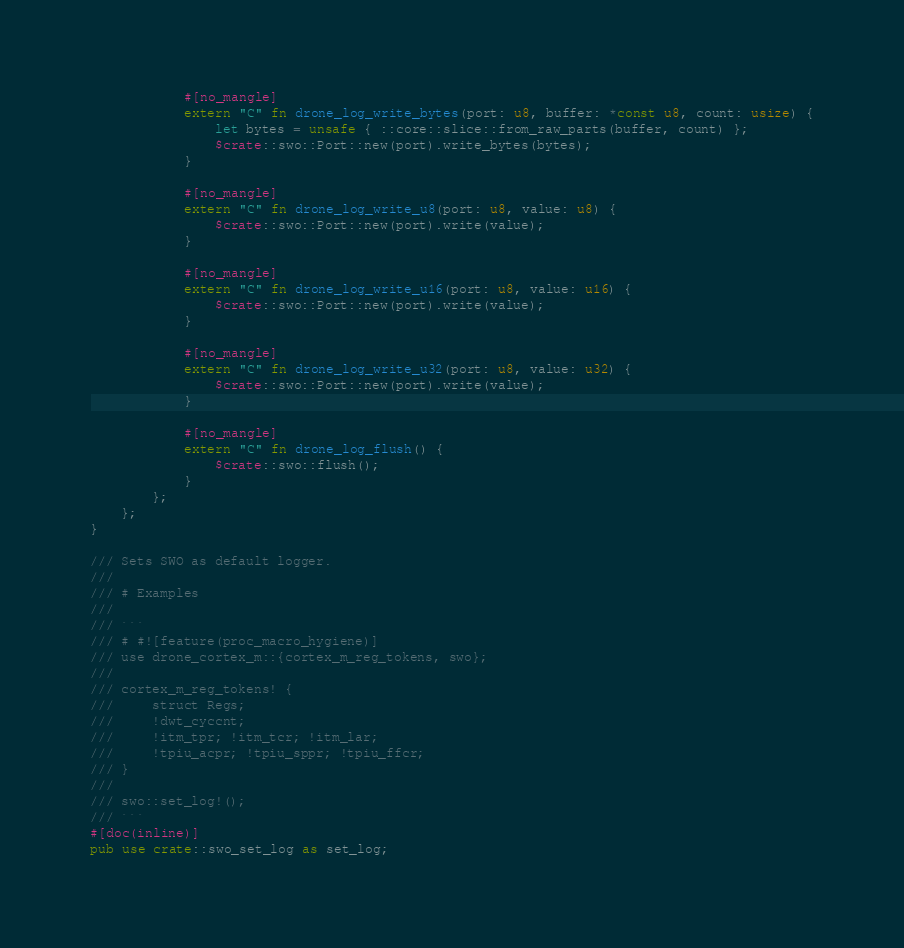Convert code to text. <code><loc_0><loc_0><loc_500><loc_500><_Rust_>            #[no_mangle]
            extern "C" fn drone_log_write_bytes(port: u8, buffer: *const u8, count: usize) {
                let bytes = unsafe { ::core::slice::from_raw_parts(buffer, count) };
                $crate::swo::Port::new(port).write_bytes(bytes);
            }

            #[no_mangle]
            extern "C" fn drone_log_write_u8(port: u8, value: u8) {
                $crate::swo::Port::new(port).write(value);
            }

            #[no_mangle]
            extern "C" fn drone_log_write_u16(port: u8, value: u16) {
                $crate::swo::Port::new(port).write(value);
            }

            #[no_mangle]
            extern "C" fn drone_log_write_u32(port: u8, value: u32) {
                $crate::swo::Port::new(port).write(value);
            }

            #[no_mangle]
            extern "C" fn drone_log_flush() {
                $crate::swo::flush();
            }
        };
    };
}

/// Sets SWO as default logger.
///
/// # Examples
///
/// ```
/// # #![feature(proc_macro_hygiene)]
/// use drone_cortex_m::{cortex_m_reg_tokens, swo};
///
/// cortex_m_reg_tokens! {
///     struct Regs;
///     !dwt_cyccnt;
///     !itm_tpr; !itm_tcr; !itm_lar;
///     !tpiu_acpr; !tpiu_sppr; !tpiu_ffcr;
/// }
///
/// swo::set_log!();
/// ```
#[doc(inline)]
pub use crate::swo_set_log as set_log;
</code> 